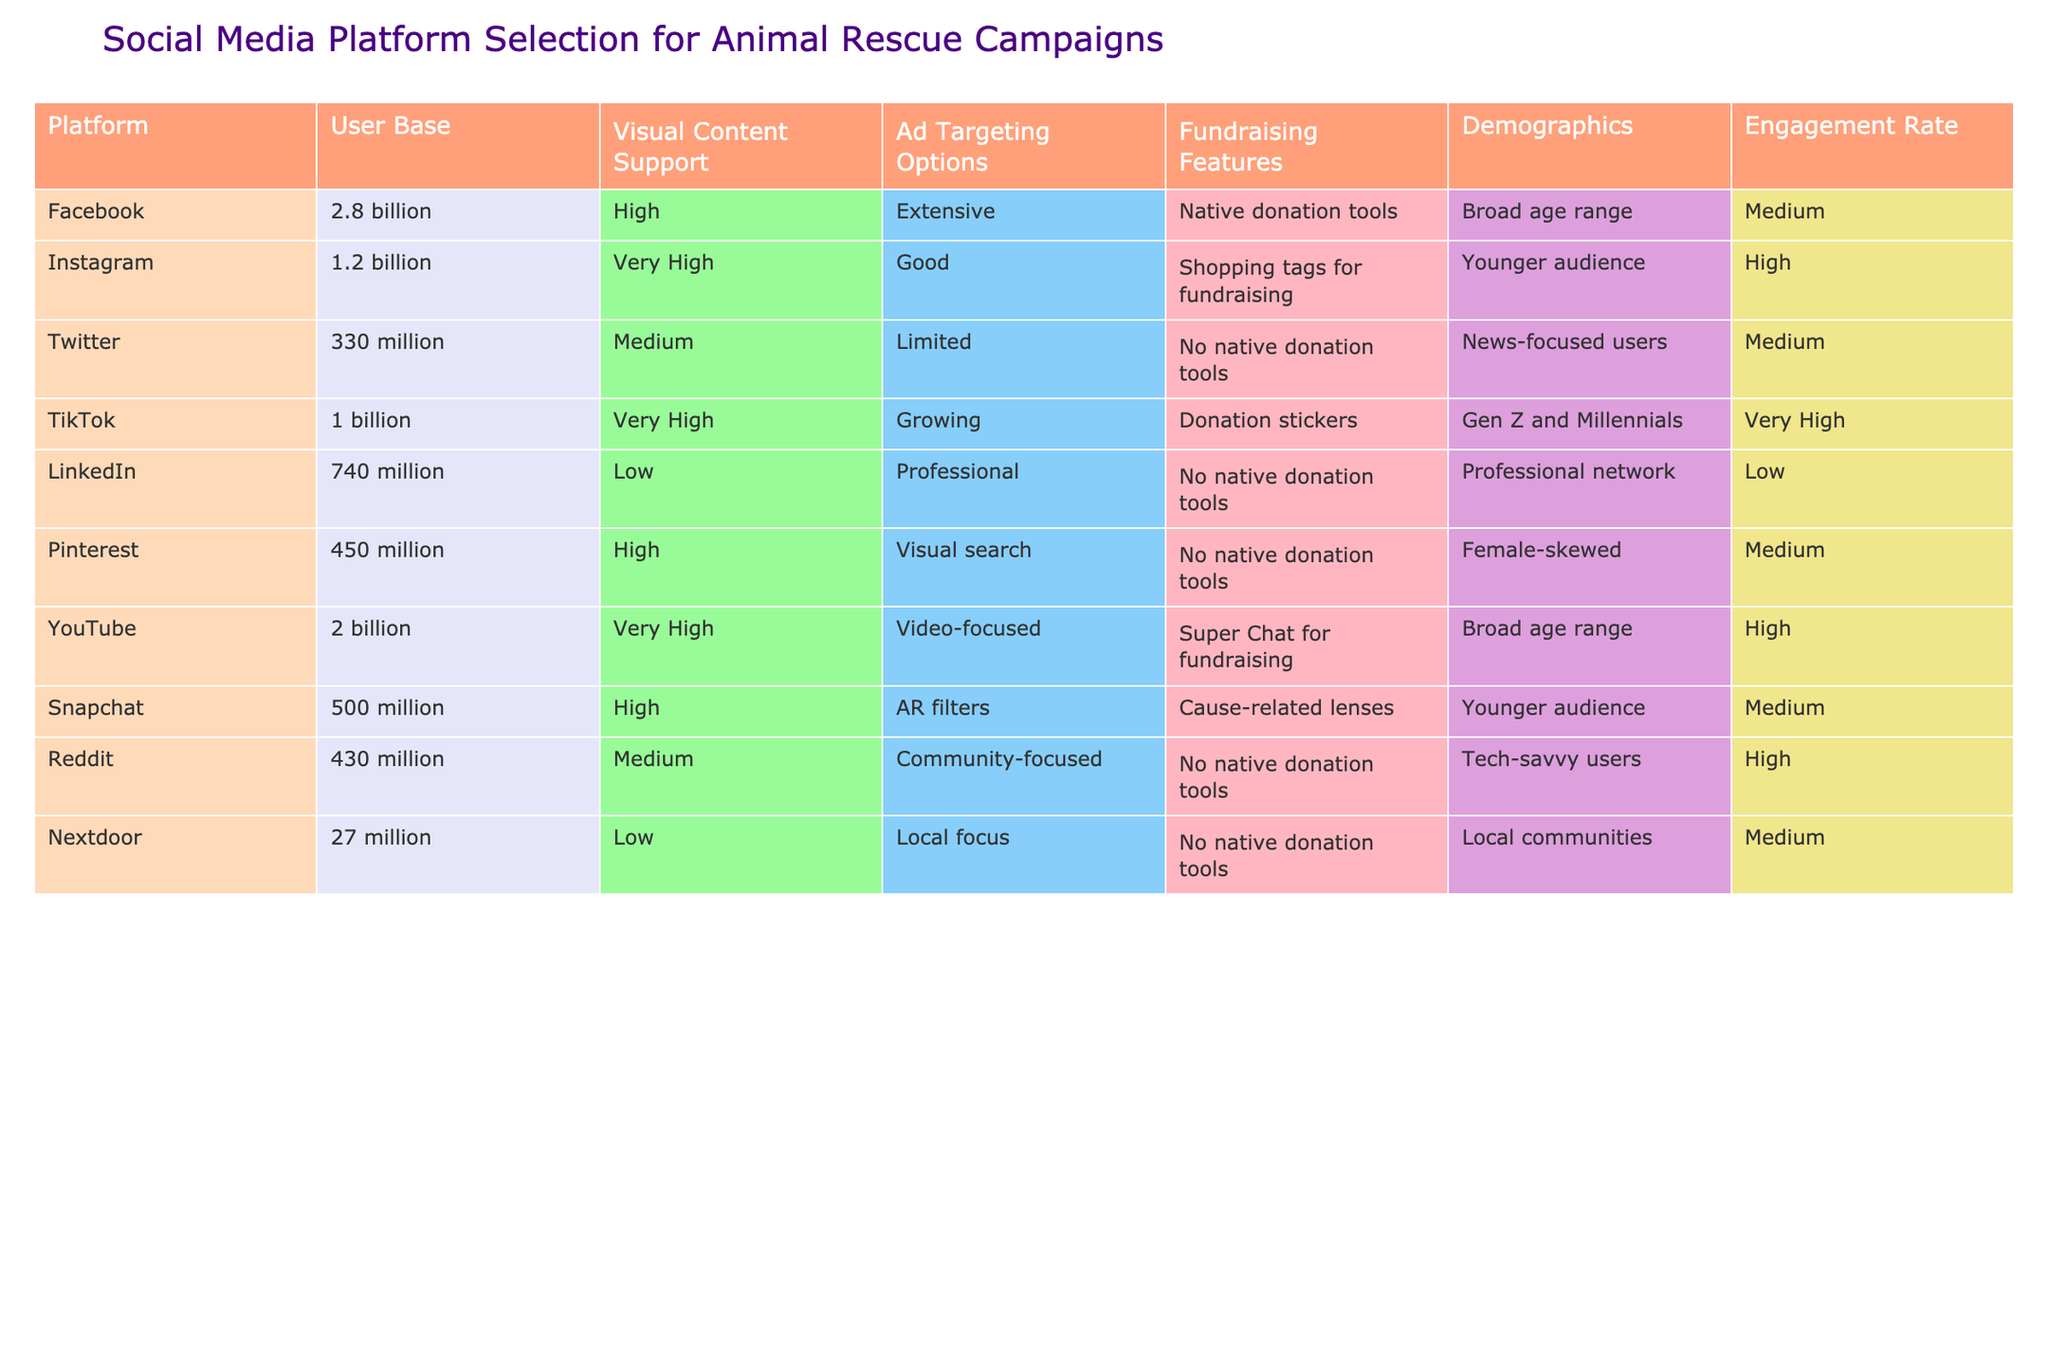What is the user base of Instagram? The table lists the user base of each platform. Instagram has a user base of 1.2 billion.
Answer: 1.2 billion Which platform has the highest support for visual content? By examining the 'Visual Content Support' column, Instagram and TikTok both have 'Very High' support for visual content.
Answer: Instagram and TikTok Does Twitter have native donation tools? The 'Ad Targeting Options' column for Twitter shows it does not have native donation tools since it is marked 'No native donation tools'.
Answer: No What is the average engagement rate of the platforms that support native donation tools? The platforms with native donation tools are Facebook, Instagram, and YouTube. Their engagement rates are Medium, High, and High respectively (converted to numerical scale: Medium=1, High=2). Average is (1+2+2)/3 = 1.67, which is approximately between Medium and High.
Answer: Between Medium and High Is TikTok's user base larger than Snapchat's? Comparing the 'User Base' of TikTok (1 billion) and Snapchat (500 million), TikTok's user base is larger since 1 billion is greater than 500 million.
Answer: Yes What platform has the highest user base with fundraising features? According to the table, Facebook (2.8 billion) has the highest user base and offers native donation tools for fundraising, making it the platform with the highest user base that also has fundraising features.
Answer: Facebook Calculate the difference in user base between the largest and smallest platforms. The largest platform is Facebook with 2.8 billion users, and the smallest is Nextdoor with 27 million users. To find the difference, convert 2.8 billion to millions: 2800 million - 27 million = 2773 million.
Answer: 2773 million What demographic does Pinterest mainly cater to? The 'Demographics' column for Pinterest specifies that it is female-skewed.
Answer: Female-skewed Which platform has the lowest engagement rate? By reviewing the 'Engagement Rate' column, LinkedIn has a 'Low' engagement rate, which is the lowest among all listed platforms.
Answer: LinkedIn 